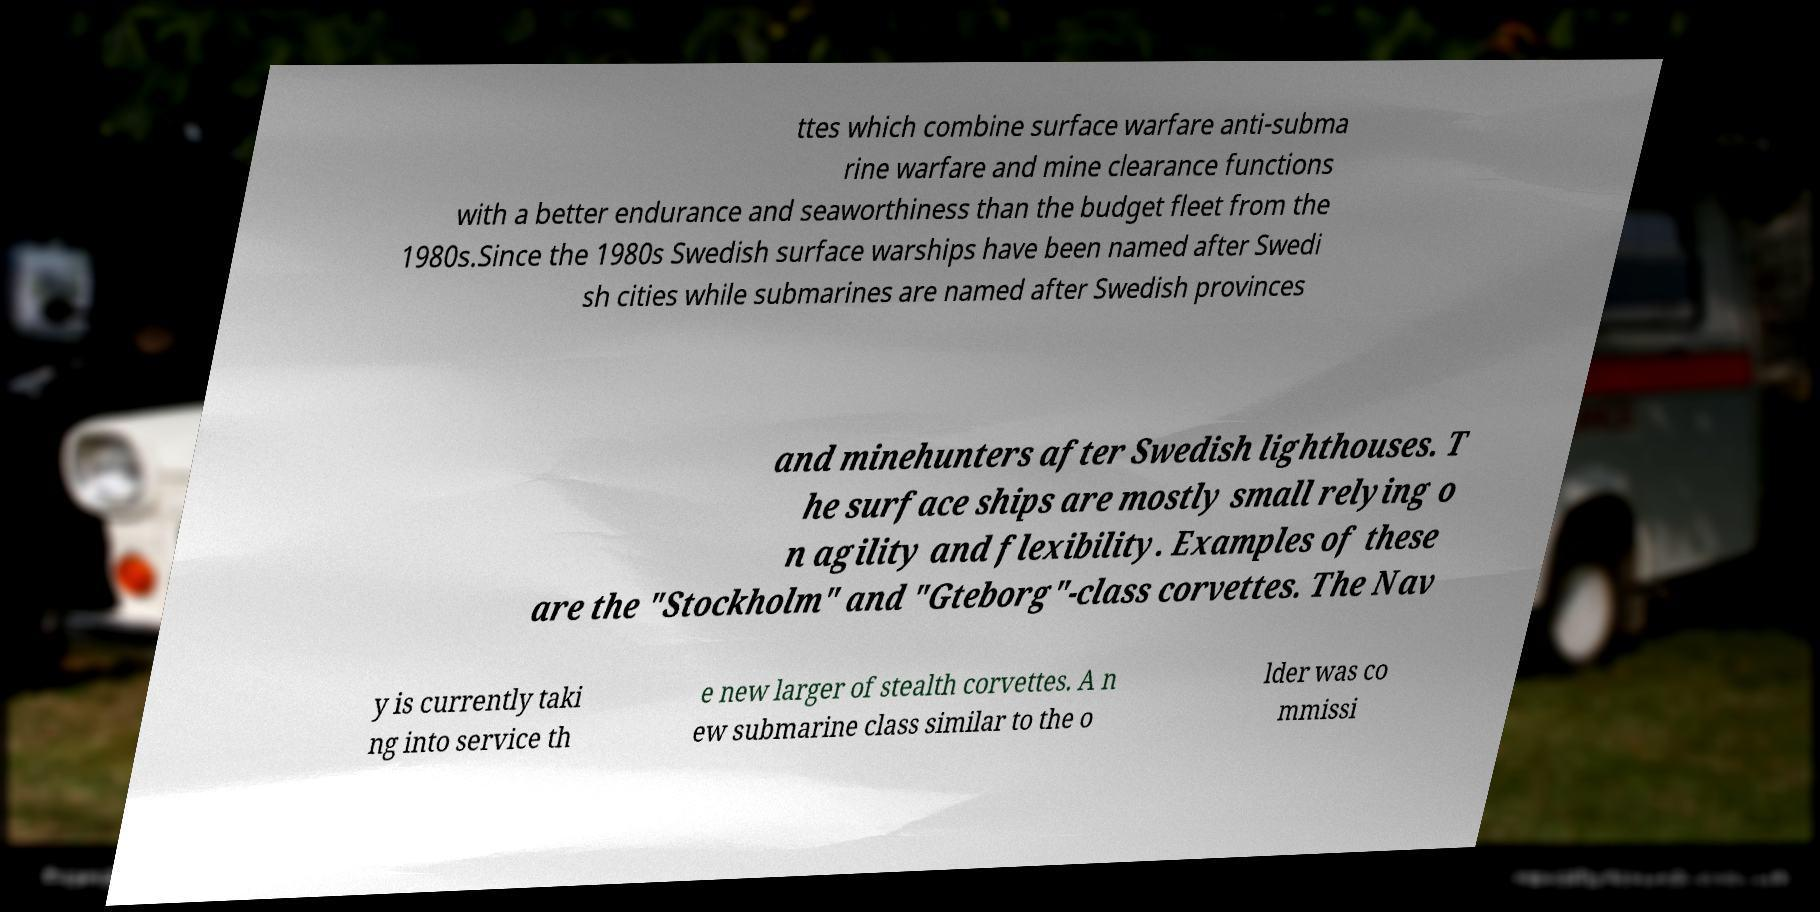For documentation purposes, I need the text within this image transcribed. Could you provide that? ttes which combine surface warfare anti-subma rine warfare and mine clearance functions with a better endurance and seaworthiness than the budget fleet from the 1980s.Since the 1980s Swedish surface warships have been named after Swedi sh cities while submarines are named after Swedish provinces and minehunters after Swedish lighthouses. T he surface ships are mostly small relying o n agility and flexibility. Examples of these are the "Stockholm" and "Gteborg"-class corvettes. The Nav y is currently taki ng into service th e new larger of stealth corvettes. A n ew submarine class similar to the o lder was co mmissi 